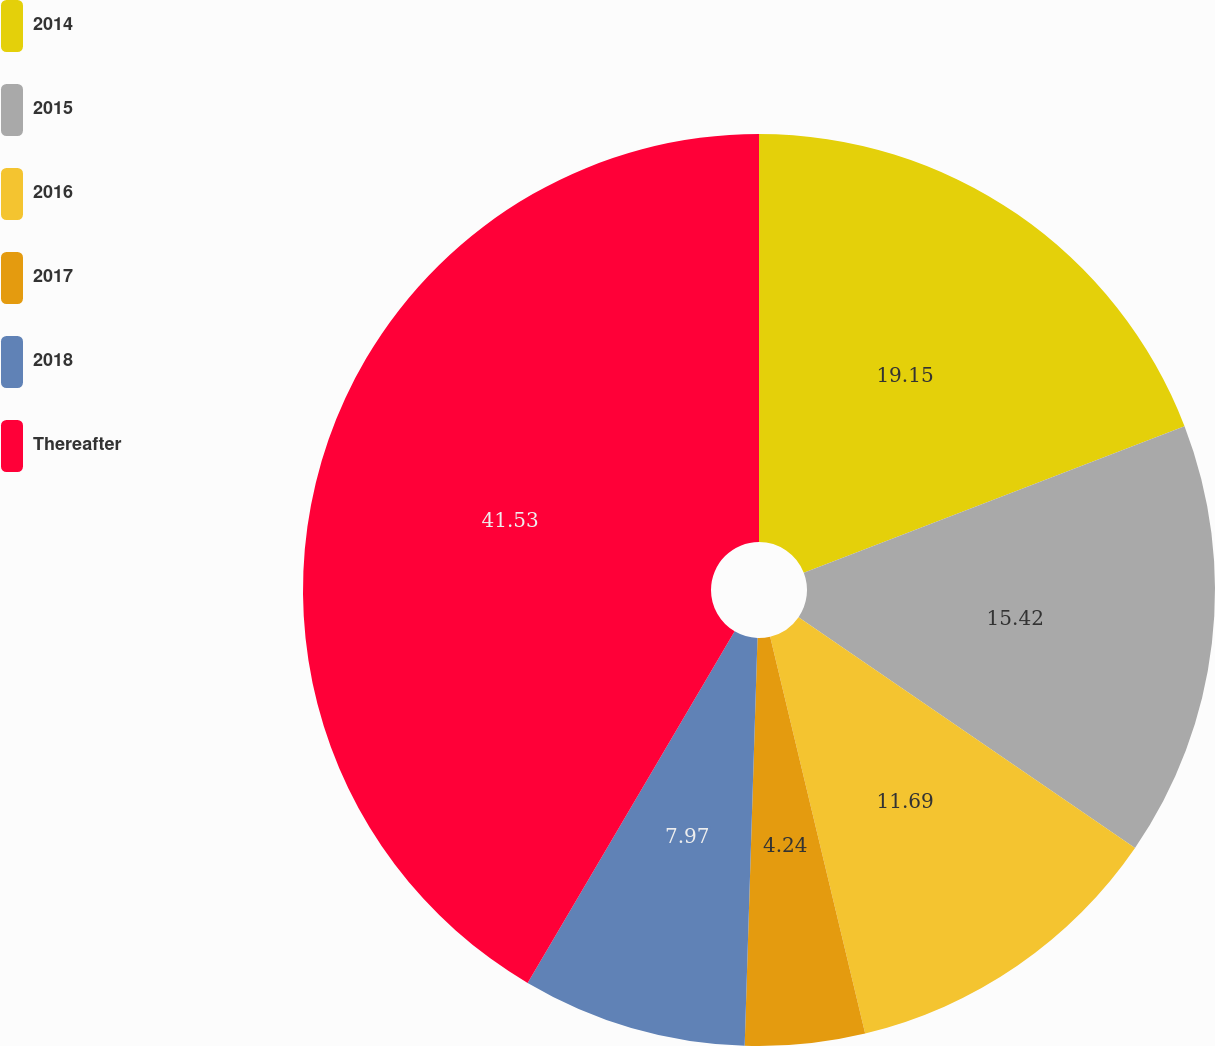<chart> <loc_0><loc_0><loc_500><loc_500><pie_chart><fcel>2014<fcel>2015<fcel>2016<fcel>2017<fcel>2018<fcel>Thereafter<nl><fcel>19.15%<fcel>15.42%<fcel>11.69%<fcel>4.24%<fcel>7.97%<fcel>41.53%<nl></chart> 